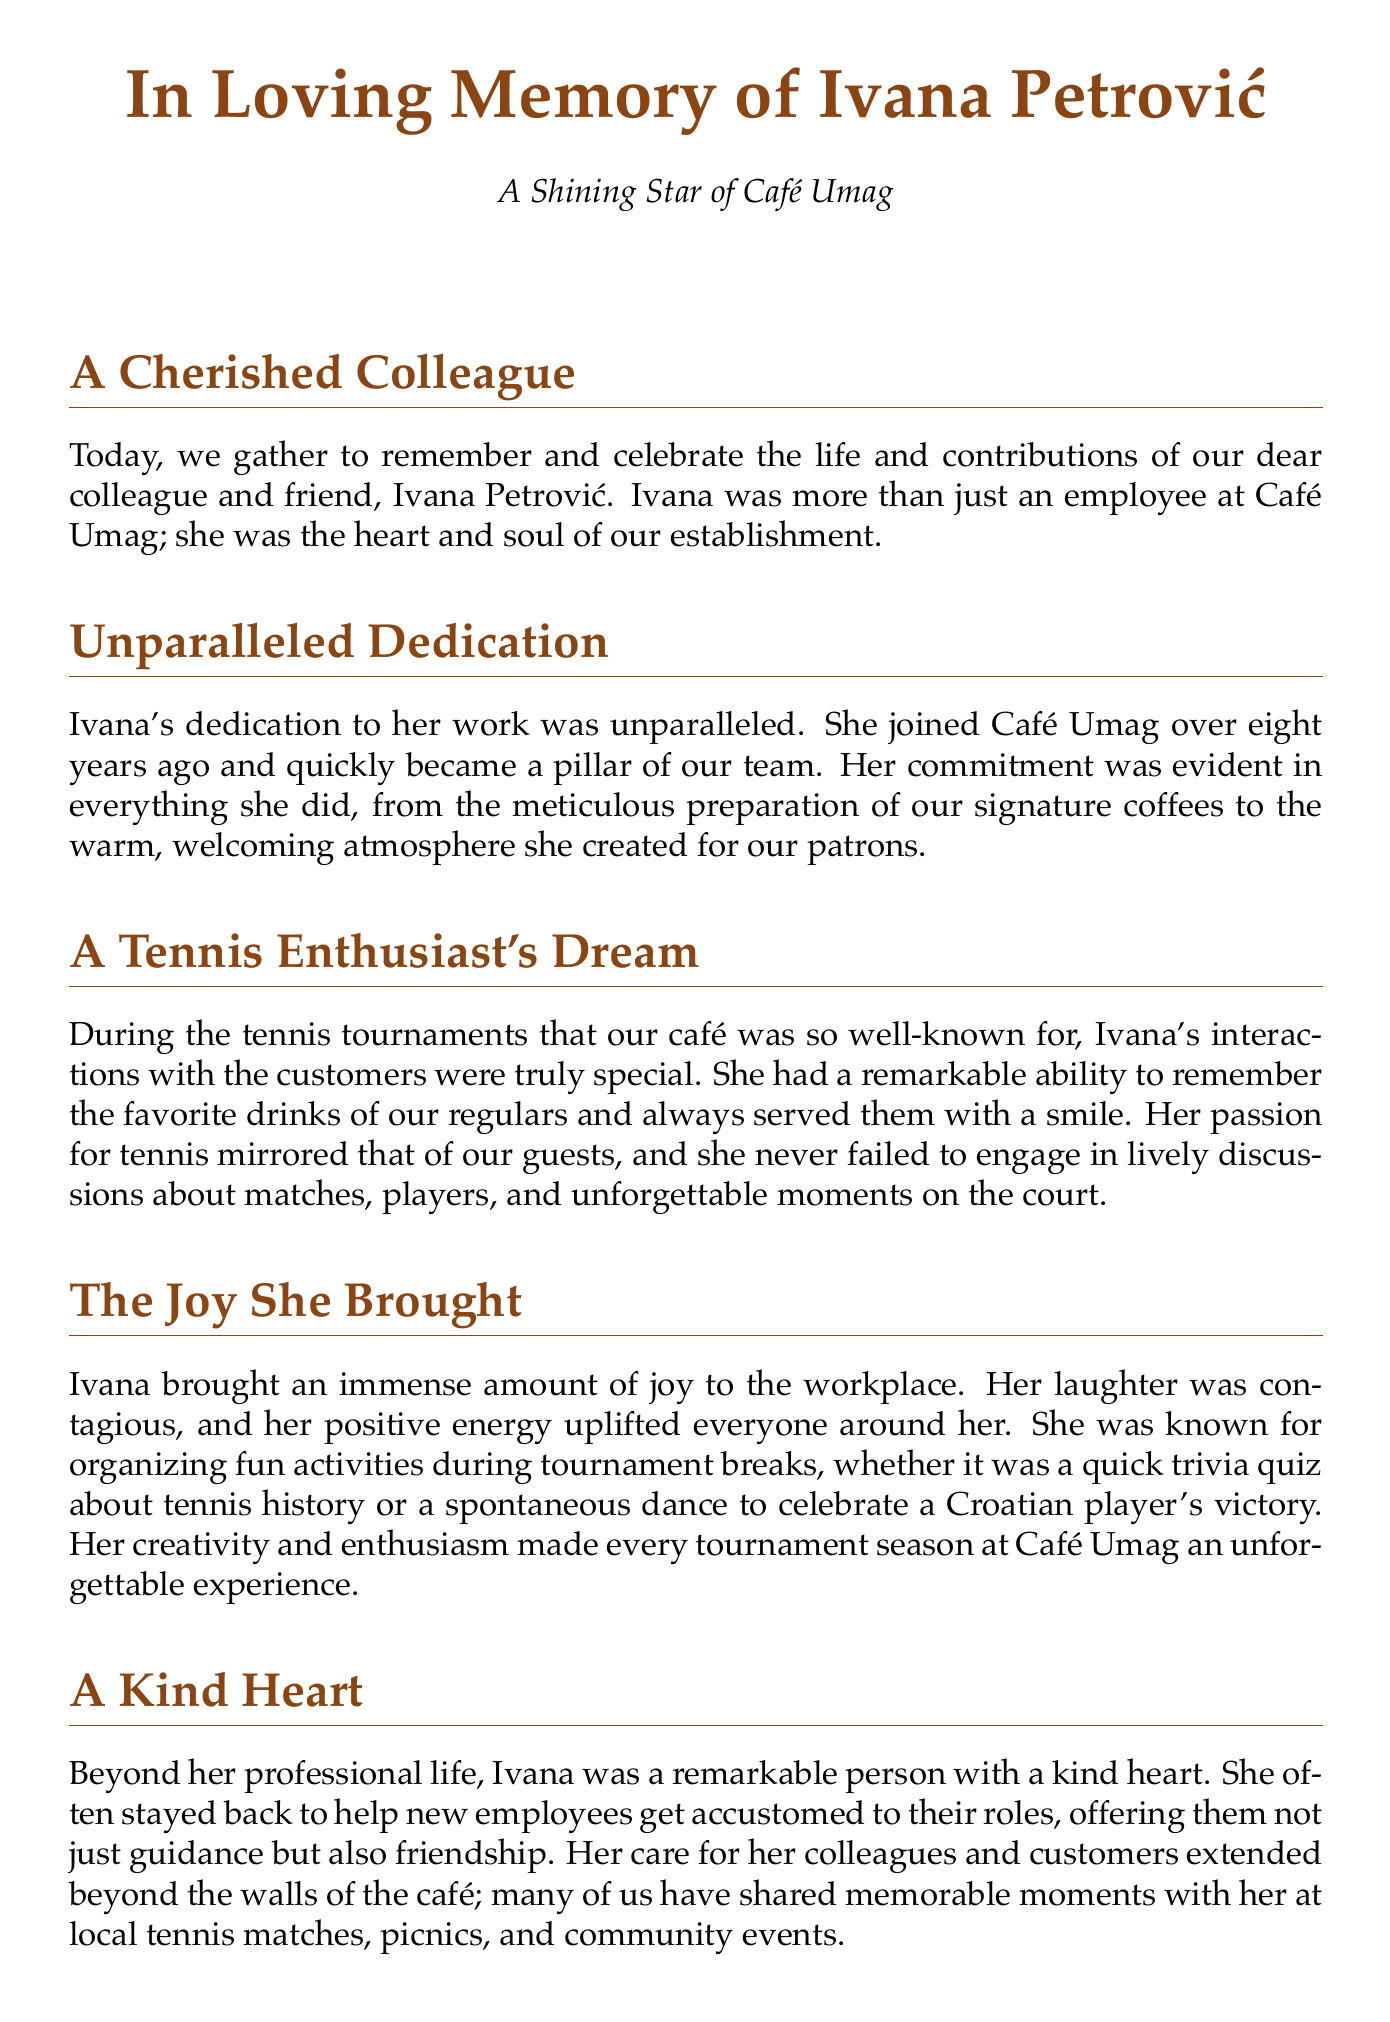What is the name of the employee being honored? The document specifically mentions the employee by name in the title, which is Ivana Petrović.
Answer: Ivana Petrović How many years did Ivana work at Café Umag? The document states that Ivana joined Café Umag over eight years ago, indicating her length of service.
Answer: over eight years What was Ivana's role at the café? The document describes her as a "valued café employee," indicating her general role within the café.
Answer: café employee What type of events did Ivana organize during tournaments? The document notes that Ivana organized fun activities during tournament breaks, specifically trivia quizzes and spontaneous dances.
Answer: trivia quiz and dance What quality made Ivana special among customers? The document highlights her ability to remember customers' favorite drinks and serve them with a smile, marking her unique engagement.
Answer: remembering favorite drinks What was one of Ivana's passions? Tennis is mentioned as a significant interest of Ivana, as she engaged customers in discussions about it.
Answer: tennis What is described as Ivana’s legacy? The document states that her legacy includes kindness, dedication, and an unwavering spirit that touched many lives.
Answer: kindness and dedication What did Ivana do for new employees? According to the document, Ivana helped new employees get accustomed to their roles, providing guidance and friendship.
Answer: helped new employees What sentiment is expressed at the end of the eulogy? The concluding sentiment emphasizes remembering Ivana's joy and continuing her cherished community spirit.
Answer: remember the joy she brought 